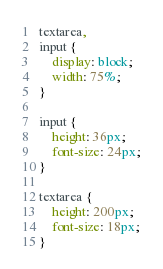<code> <loc_0><loc_0><loc_500><loc_500><_CSS_>textarea,
input {
    display: block;
    width: 75%;
}

input {
    height: 36px;
    font-size: 24px;
}

textarea {
    height: 200px;
    font-size: 18px;
}</code> 